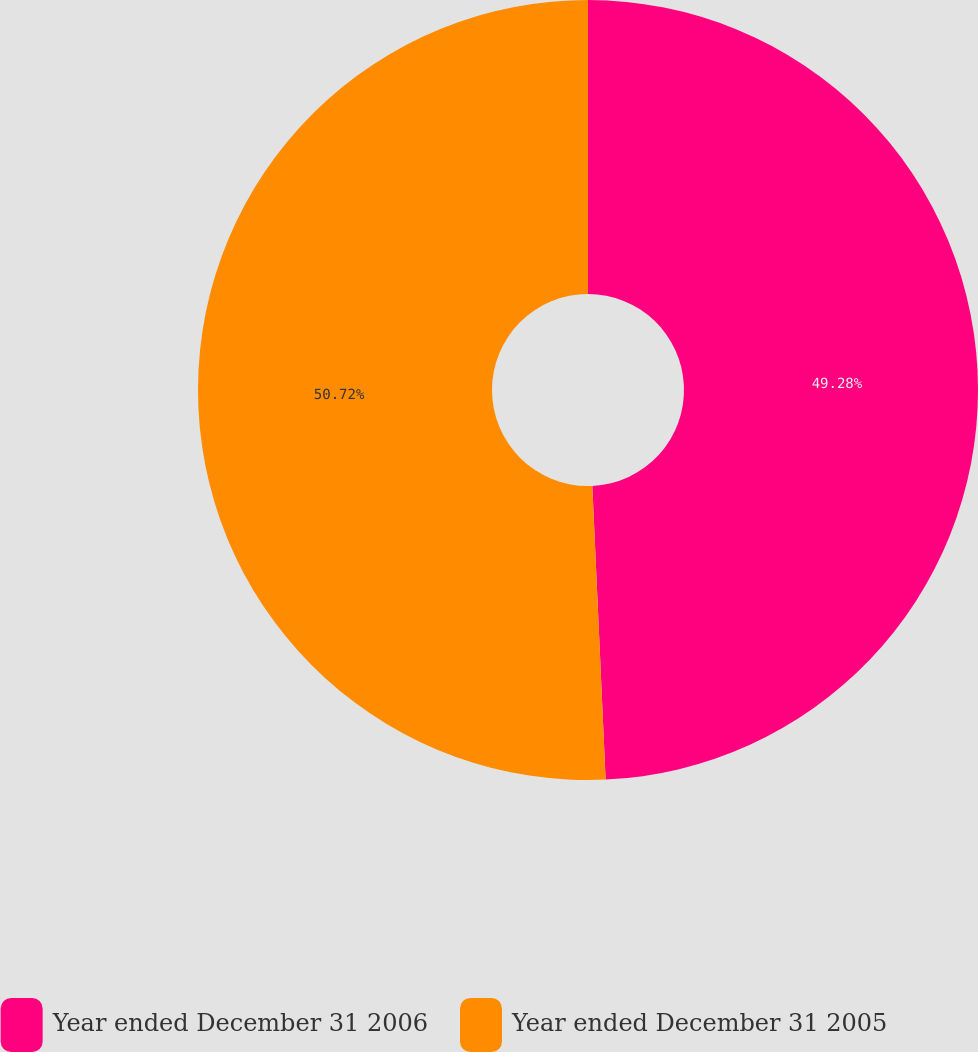<chart> <loc_0><loc_0><loc_500><loc_500><pie_chart><fcel>Year ended December 31 2006<fcel>Year ended December 31 2005<nl><fcel>49.28%<fcel>50.72%<nl></chart> 